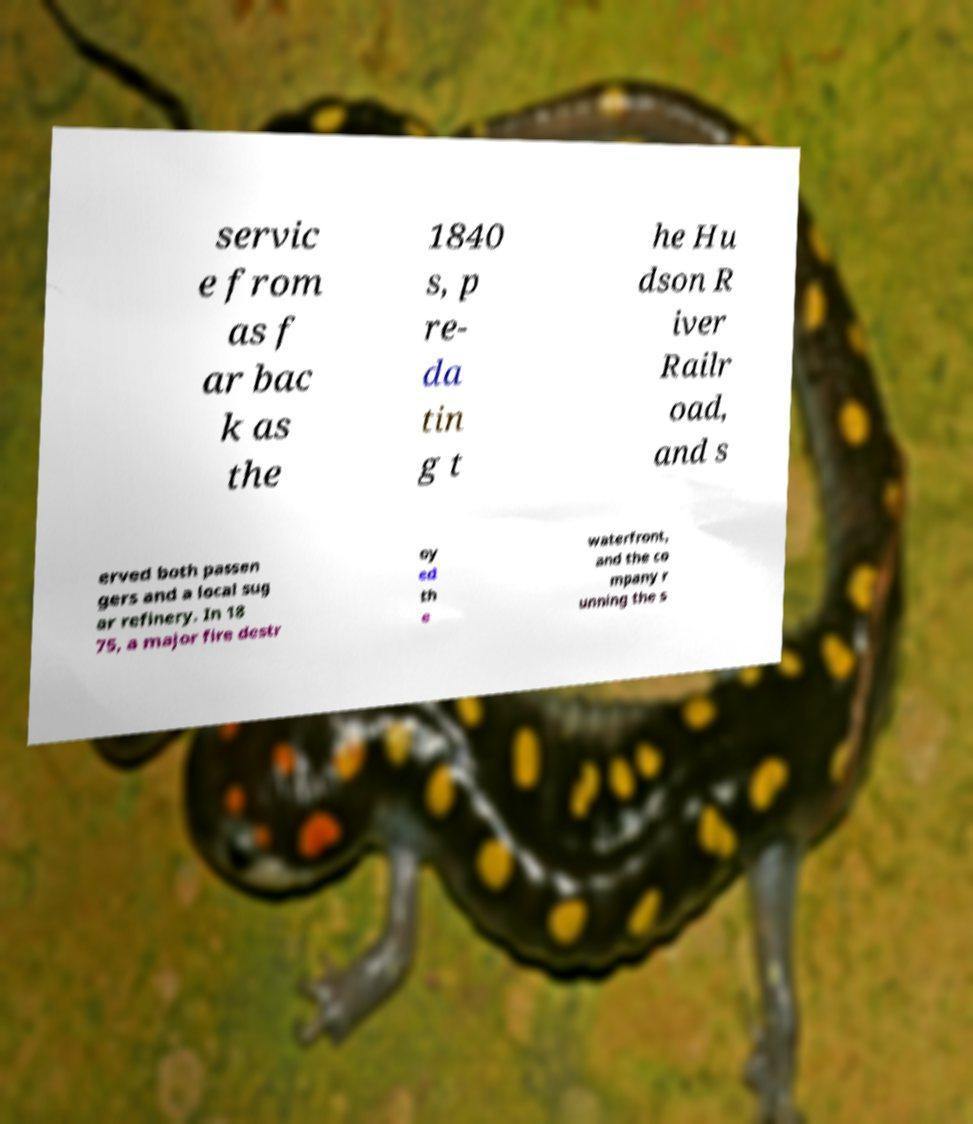For documentation purposes, I need the text within this image transcribed. Could you provide that? servic e from as f ar bac k as the 1840 s, p re- da tin g t he Hu dson R iver Railr oad, and s erved both passen gers and a local sug ar refinery. In 18 75, a major fire destr oy ed th e waterfront, and the co mpany r unning the s 